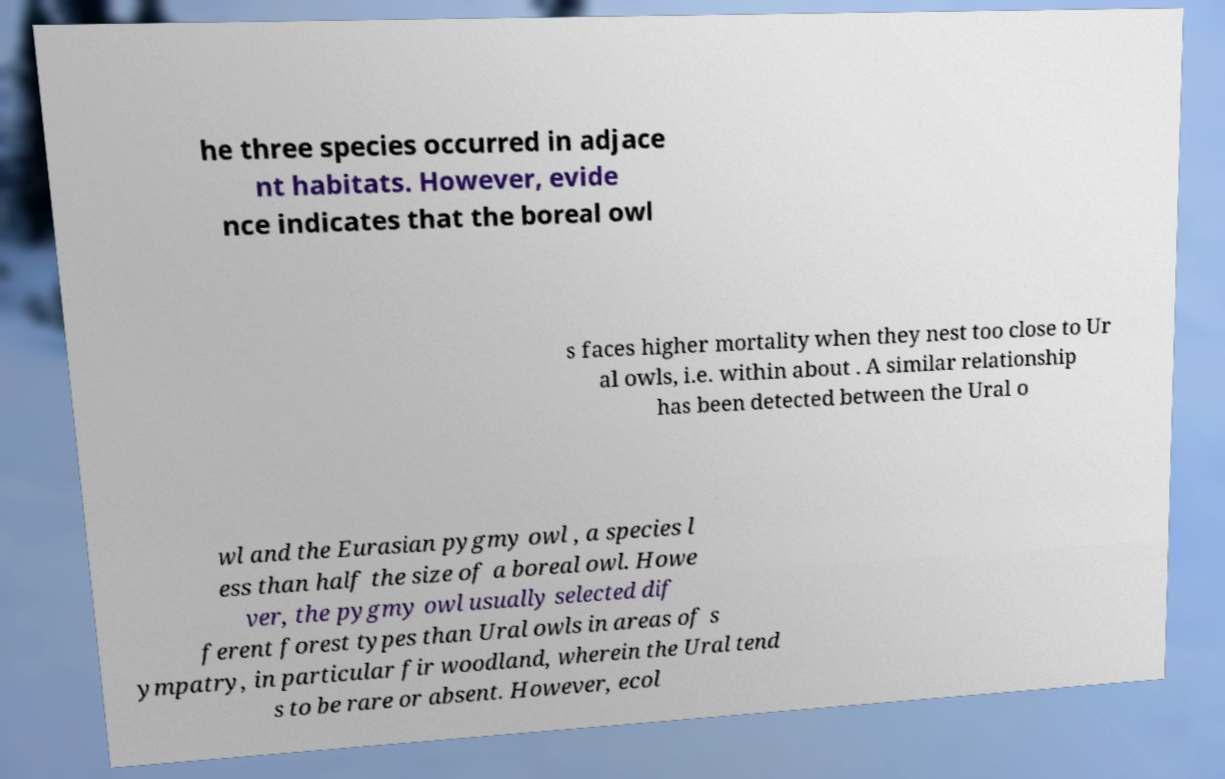What messages or text are displayed in this image? I need them in a readable, typed format. he three species occurred in adjace nt habitats. However, evide nce indicates that the boreal owl s faces higher mortality when they nest too close to Ur al owls, i.e. within about . A similar relationship has been detected between the Ural o wl and the Eurasian pygmy owl , a species l ess than half the size of a boreal owl. Howe ver, the pygmy owl usually selected dif ferent forest types than Ural owls in areas of s ympatry, in particular fir woodland, wherein the Ural tend s to be rare or absent. However, ecol 